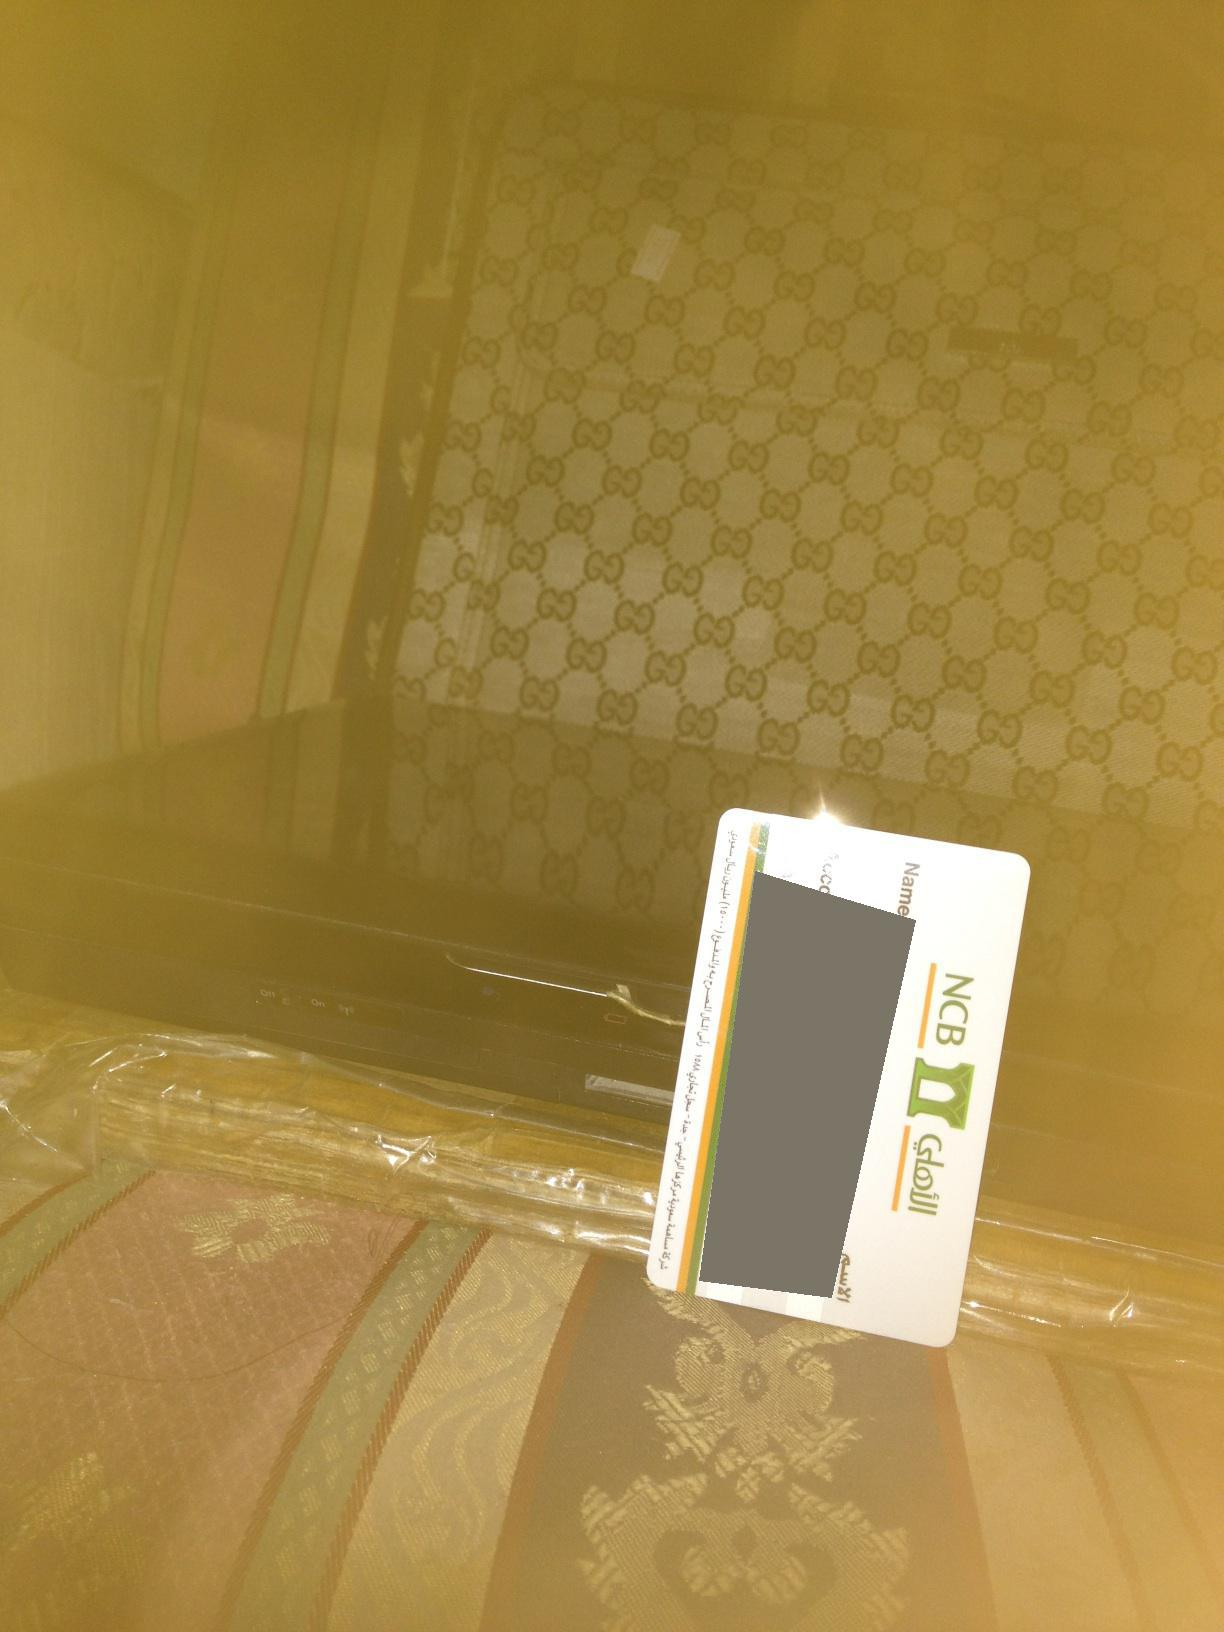Describe a realistic but detailed scene where the person has just finished shopping and returned home. The individual has just returned home from an upscale shopping spree in the city. They've placed their new luxury suitcase on the couch, the distinctive pattern hinting at its brand and cost. Their corporate credit card lies on top, implying it was used extensively today. The golden tint around the picture gives a warm, cozy feel, suggesting it's evening and perhaps the room is lit by a soft, ambient lighting. Underneath the suitcase, wrapped carefully in transparent plastic, is their latest tech acquisition - maybe a new entertainment system or a high-end gadget. They meticulously unpack their purchases, savoring the satisfaction and perhaps planning to enjoy their new tech gadget for a quiet evening at home. The atmosphere speaks of a blend of excitement, satisfaction, and a bit of fatigue after a long day of rewarding shopping. 